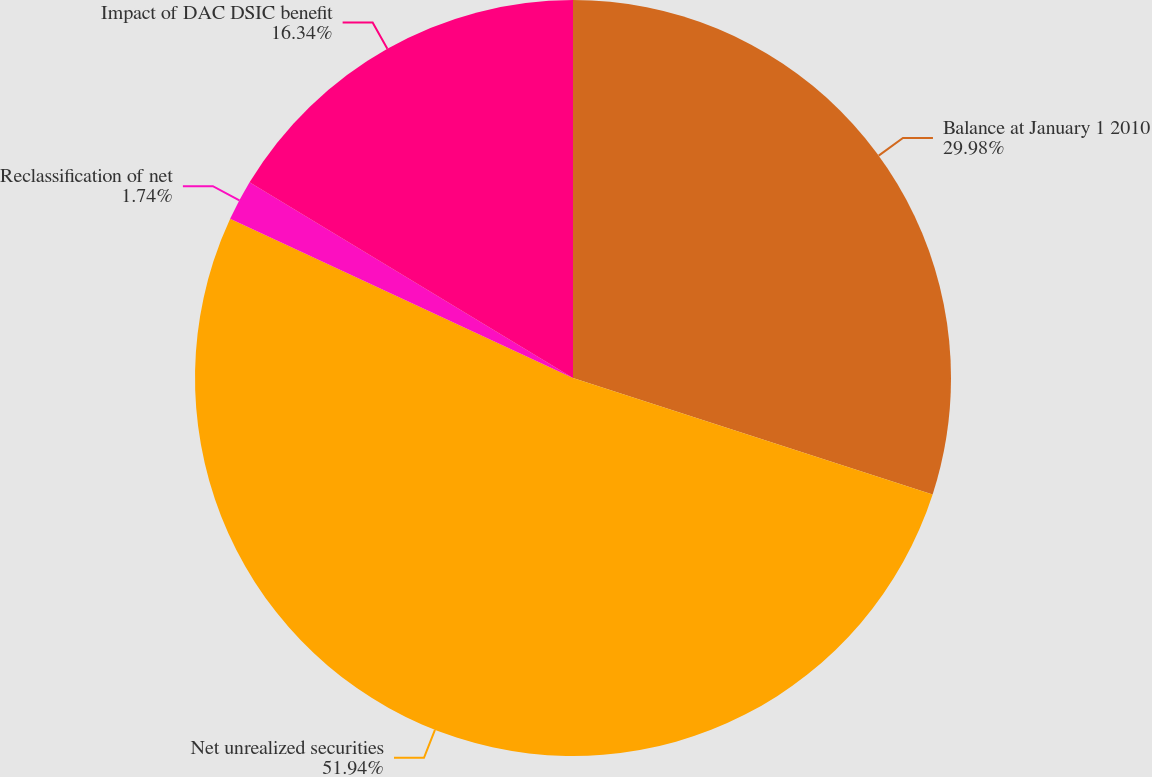Convert chart. <chart><loc_0><loc_0><loc_500><loc_500><pie_chart><fcel>Balance at January 1 2010<fcel>Net unrealized securities<fcel>Reclassification of net<fcel>Impact of DAC DSIC benefit<nl><fcel>29.98%<fcel>51.93%<fcel>1.74%<fcel>16.34%<nl></chart> 